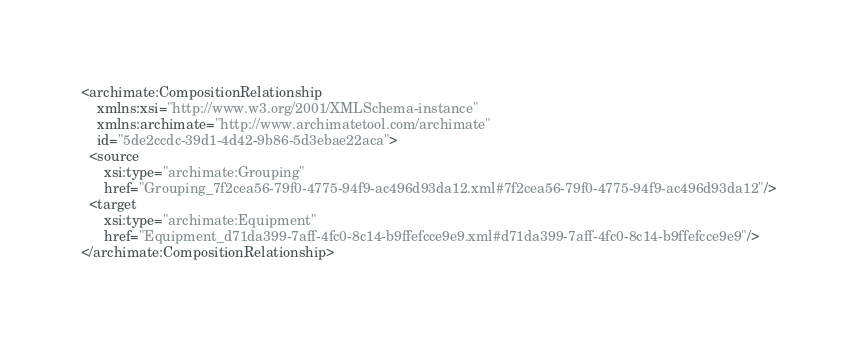<code> <loc_0><loc_0><loc_500><loc_500><_XML_><archimate:CompositionRelationship
    xmlns:xsi="http://www.w3.org/2001/XMLSchema-instance"
    xmlns:archimate="http://www.archimatetool.com/archimate"
    id="5de2ccdc-39d1-4d42-9b86-5d3ebae22aca">
  <source
      xsi:type="archimate:Grouping"
      href="Grouping_7f2cea56-79f0-4775-94f9-ac496d93da12.xml#7f2cea56-79f0-4775-94f9-ac496d93da12"/>
  <target
      xsi:type="archimate:Equipment"
      href="Equipment_d71da399-7aff-4fc0-8c14-b9ffefcce9e9.xml#d71da399-7aff-4fc0-8c14-b9ffefcce9e9"/>
</archimate:CompositionRelationship>
</code> 